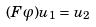<formula> <loc_0><loc_0><loc_500><loc_500>( F \varphi ) u _ { 1 } = u _ { 2 }</formula> 